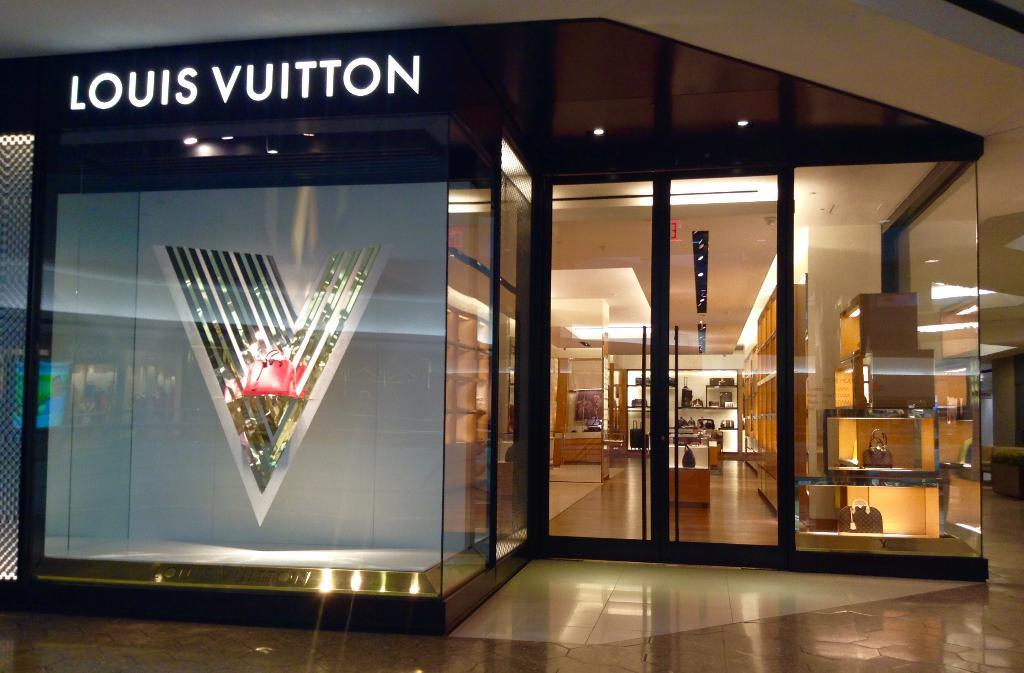<image>
Relay a brief, clear account of the picture shown. The outside of  a Louis Vuitton store, with glass windows and doors. 